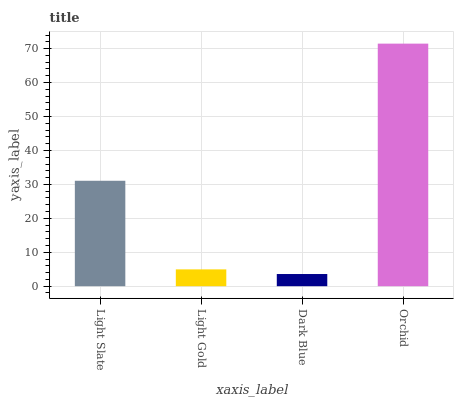Is Dark Blue the minimum?
Answer yes or no. Yes. Is Orchid the maximum?
Answer yes or no. Yes. Is Light Gold the minimum?
Answer yes or no. No. Is Light Gold the maximum?
Answer yes or no. No. Is Light Slate greater than Light Gold?
Answer yes or no. Yes. Is Light Gold less than Light Slate?
Answer yes or no. Yes. Is Light Gold greater than Light Slate?
Answer yes or no. No. Is Light Slate less than Light Gold?
Answer yes or no. No. Is Light Slate the high median?
Answer yes or no. Yes. Is Light Gold the low median?
Answer yes or no. Yes. Is Dark Blue the high median?
Answer yes or no. No. Is Dark Blue the low median?
Answer yes or no. No. 